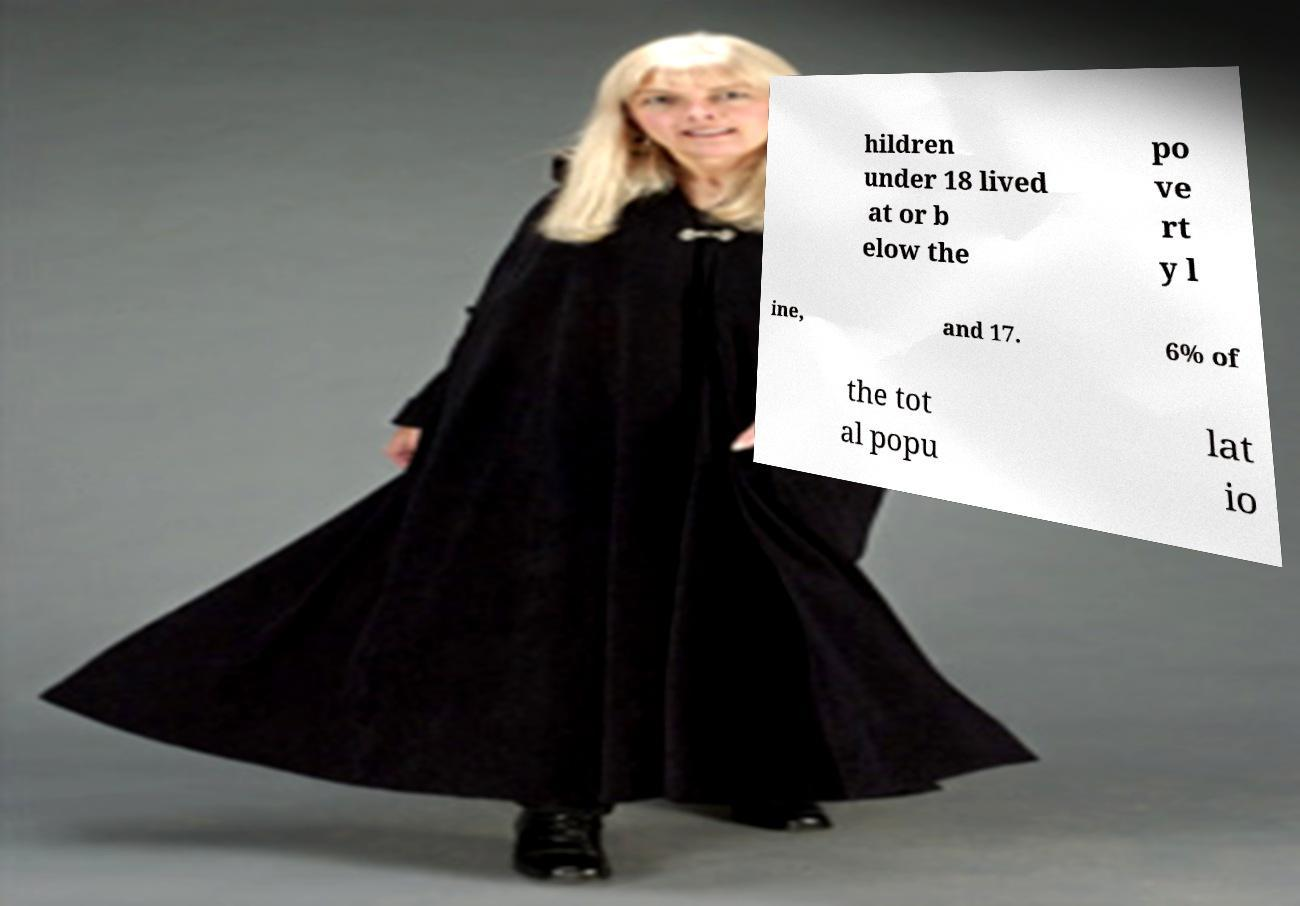What messages or text are displayed in this image? I need them in a readable, typed format. hildren under 18 lived at or b elow the po ve rt y l ine, and 17. 6% of the tot al popu lat io 